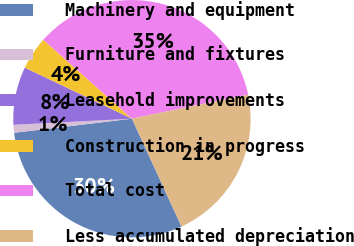Convert chart to OTSL. <chart><loc_0><loc_0><loc_500><loc_500><pie_chart><fcel>Machinery and equipment<fcel>Furniture and fixtures<fcel>Leasehold improvements<fcel>Construction in progress<fcel>Total cost<fcel>Less accumulated depreciation<nl><fcel>29.96%<fcel>1.08%<fcel>7.9%<fcel>4.49%<fcel>35.18%<fcel>21.39%<nl></chart> 